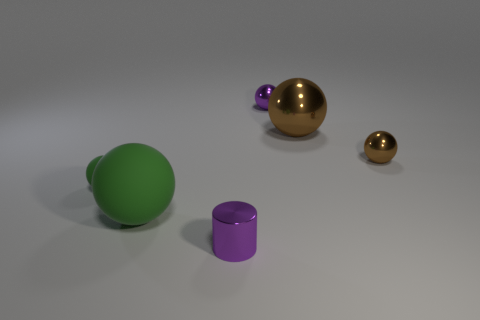Is there any other thing that is the same size as the purple ball?
Provide a short and direct response. Yes. There is a shiny sphere that is left of the small brown metal object and in front of the small purple ball; what size is it?
Offer a very short reply. Large. Do the big brown metallic thing and the big rubber thing have the same shape?
Give a very brief answer. Yes. There is a big brown thing that is made of the same material as the small purple cylinder; what is its shape?
Make the answer very short. Sphere. What number of small things are either purple shiny balls or brown objects?
Your answer should be very brief. 2. There is a small purple object that is to the right of the metallic cylinder; are there any objects that are in front of it?
Your response must be concise. Yes. Are any tiny blue spheres visible?
Your response must be concise. No. The small metallic sphere that is on the right side of the big thing to the right of the tiny metal cylinder is what color?
Make the answer very short. Brown. There is a purple object that is the same shape as the small green object; what material is it?
Provide a short and direct response. Metal. What number of green matte blocks are the same size as the purple cylinder?
Your response must be concise. 0. 